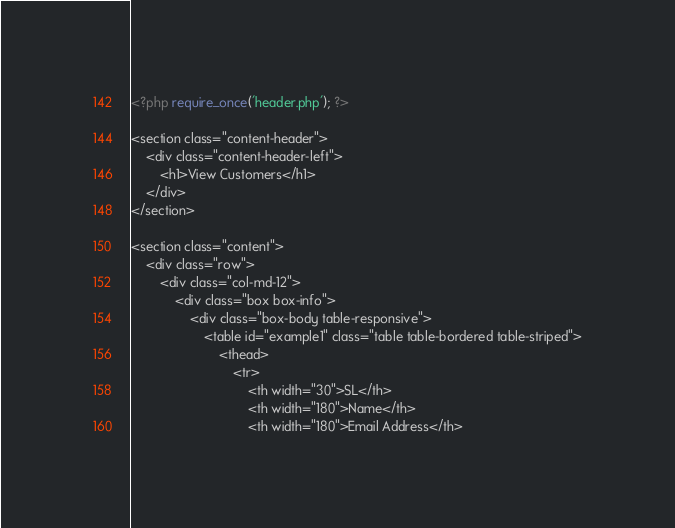<code> <loc_0><loc_0><loc_500><loc_500><_PHP_><?php require_once('header.php'); ?>

<section class="content-header">
	<div class="content-header-left">
		<h1>View Customers</h1>
	</div>
</section>

<section class="content">
	<div class="row">
		<div class="col-md-12">
			<div class="box box-info">
				<div class="box-body table-responsive">
					<table id="example1" class="table table-bordered table-striped">
						<thead>
							<tr>
								<th width="30">SL</th>
								<th width="180">Name</th>
								<th width="180">Email Address</th></code> 